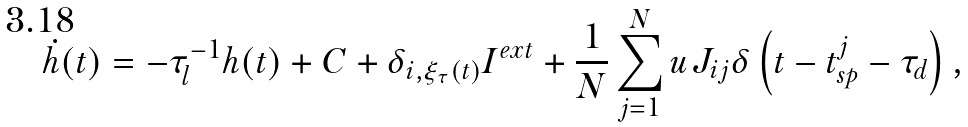<formula> <loc_0><loc_0><loc_500><loc_500>\dot { h } ( t ) = - \tau _ { l } ^ { - 1 } h ( t ) + C + \delta _ { i , \xi _ { \tau } ( t ) } I ^ { e x t } + \frac { 1 } { N } \sum _ { j = 1 } ^ { N } u J _ { i j } \delta \left ( t - t _ { s p } ^ { j } - \tau _ { d } \right ) ,</formula> 